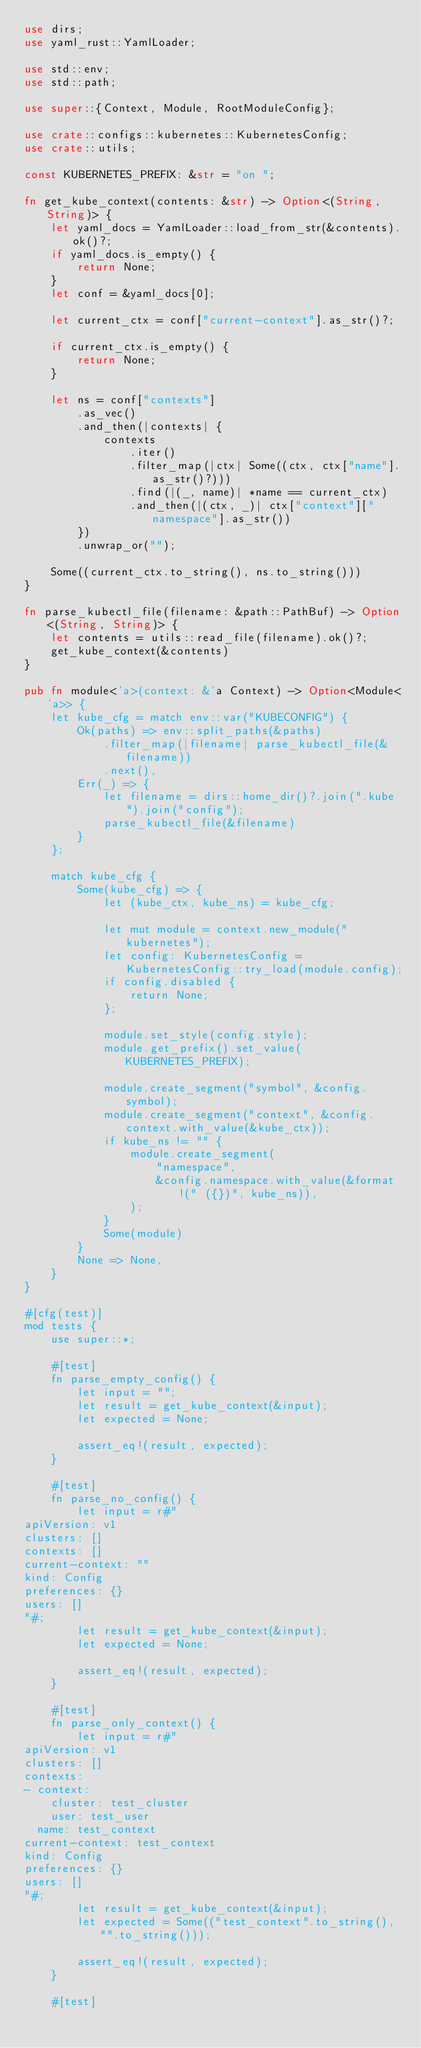<code> <loc_0><loc_0><loc_500><loc_500><_Rust_>use dirs;
use yaml_rust::YamlLoader;

use std::env;
use std::path;

use super::{Context, Module, RootModuleConfig};

use crate::configs::kubernetes::KubernetesConfig;
use crate::utils;

const KUBERNETES_PREFIX: &str = "on ";

fn get_kube_context(contents: &str) -> Option<(String, String)> {
    let yaml_docs = YamlLoader::load_from_str(&contents).ok()?;
    if yaml_docs.is_empty() {
        return None;
    }
    let conf = &yaml_docs[0];

    let current_ctx = conf["current-context"].as_str()?;

    if current_ctx.is_empty() {
        return None;
    }

    let ns = conf["contexts"]
        .as_vec()
        .and_then(|contexts| {
            contexts
                .iter()
                .filter_map(|ctx| Some((ctx, ctx["name"].as_str()?)))
                .find(|(_, name)| *name == current_ctx)
                .and_then(|(ctx, _)| ctx["context"]["namespace"].as_str())
        })
        .unwrap_or("");

    Some((current_ctx.to_string(), ns.to_string()))
}

fn parse_kubectl_file(filename: &path::PathBuf) -> Option<(String, String)> {
    let contents = utils::read_file(filename).ok()?;
    get_kube_context(&contents)
}

pub fn module<'a>(context: &'a Context) -> Option<Module<'a>> {
    let kube_cfg = match env::var("KUBECONFIG") {
        Ok(paths) => env::split_paths(&paths)
            .filter_map(|filename| parse_kubectl_file(&filename))
            .next(),
        Err(_) => {
            let filename = dirs::home_dir()?.join(".kube").join("config");
            parse_kubectl_file(&filename)
        }
    };

    match kube_cfg {
        Some(kube_cfg) => {
            let (kube_ctx, kube_ns) = kube_cfg;

            let mut module = context.new_module("kubernetes");
            let config: KubernetesConfig = KubernetesConfig::try_load(module.config);
            if config.disabled {
                return None;
            };

            module.set_style(config.style);
            module.get_prefix().set_value(KUBERNETES_PREFIX);

            module.create_segment("symbol", &config.symbol);
            module.create_segment("context", &config.context.with_value(&kube_ctx));
            if kube_ns != "" {
                module.create_segment(
                    "namespace",
                    &config.namespace.with_value(&format!(" ({})", kube_ns)),
                );
            }
            Some(module)
        }
        None => None,
    }
}

#[cfg(test)]
mod tests {
    use super::*;

    #[test]
    fn parse_empty_config() {
        let input = "";
        let result = get_kube_context(&input);
        let expected = None;

        assert_eq!(result, expected);
    }

    #[test]
    fn parse_no_config() {
        let input = r#"
apiVersion: v1
clusters: []
contexts: []
current-context: ""
kind: Config
preferences: {}
users: []
"#;
        let result = get_kube_context(&input);
        let expected = None;

        assert_eq!(result, expected);
    }

    #[test]
    fn parse_only_context() {
        let input = r#"
apiVersion: v1
clusters: []
contexts:
- context:
    cluster: test_cluster
    user: test_user
  name: test_context
current-context: test_context
kind: Config
preferences: {}
users: []
"#;
        let result = get_kube_context(&input);
        let expected = Some(("test_context".to_string(), "".to_string()));

        assert_eq!(result, expected);
    }

    #[test]</code> 